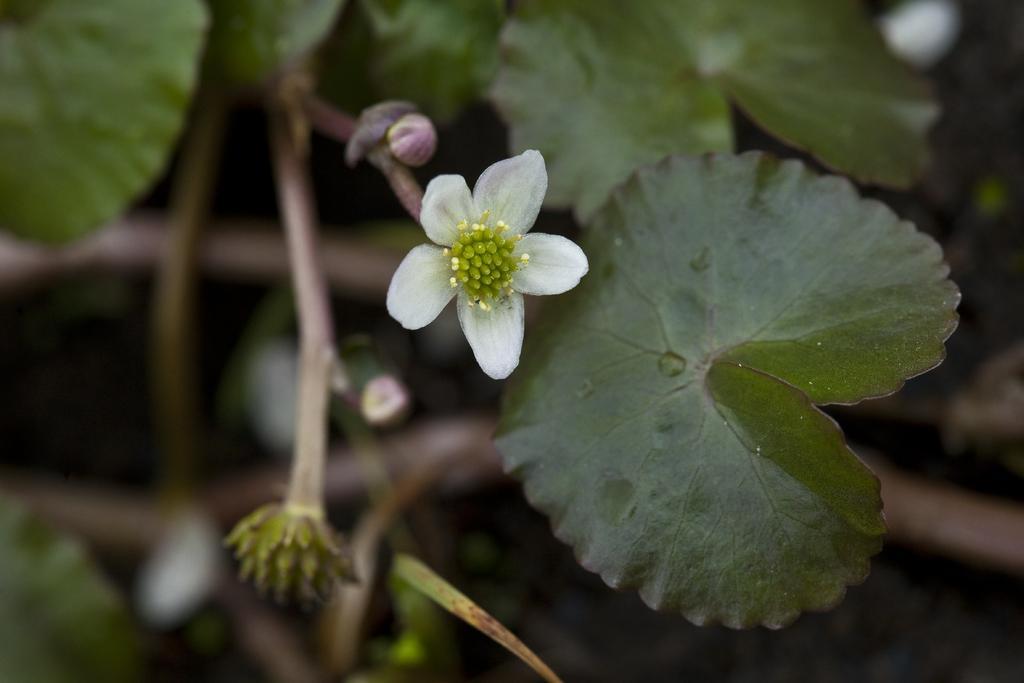How would you summarize this image in a sentence or two? This picture contains a plant which has a flower. This flower is in white color. In the background, it is blurred. 